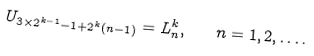Convert formula to latex. <formula><loc_0><loc_0><loc_500><loc_500>U _ { 3 \times 2 ^ { k - 1 } - 1 + 2 ^ { k } ( n - 1 ) } = L ^ { k } _ { n } , \quad n = 1 , 2 , \dots .</formula> 